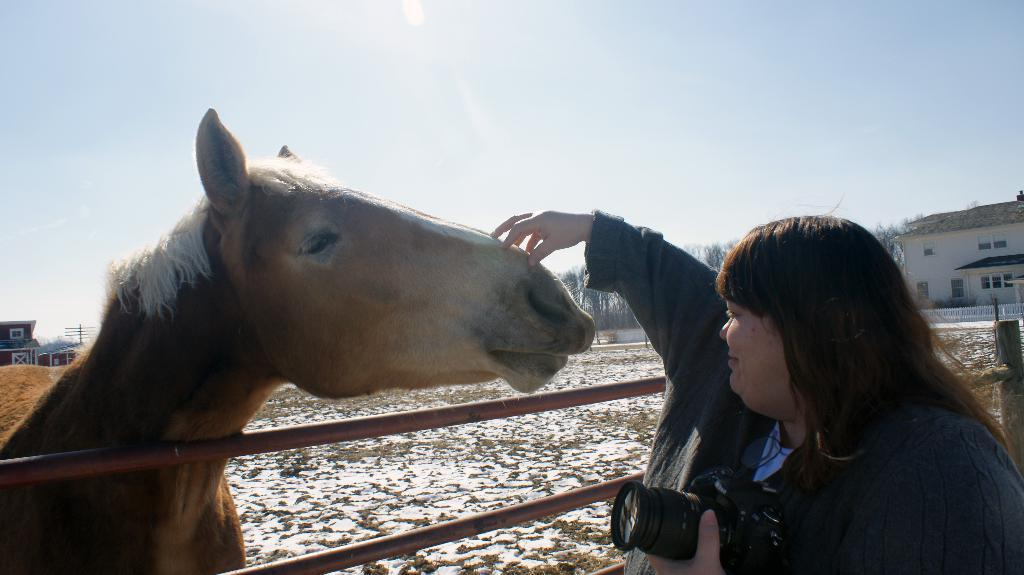Who is present in the image? There is a woman in the image. What is the woman doing in the image? The woman is standing and smiling in the image. What is the woman holding in her hands? The woman is holding a camera in her hands. What is in front of the woman? There is a horse in front of the woman. What can be seen above the woman in the image? The sky is visible above the woman. What type of clam is the woman using to take the picture in the image? There is no clam present in the image; the woman is holding a camera to take the picture. 